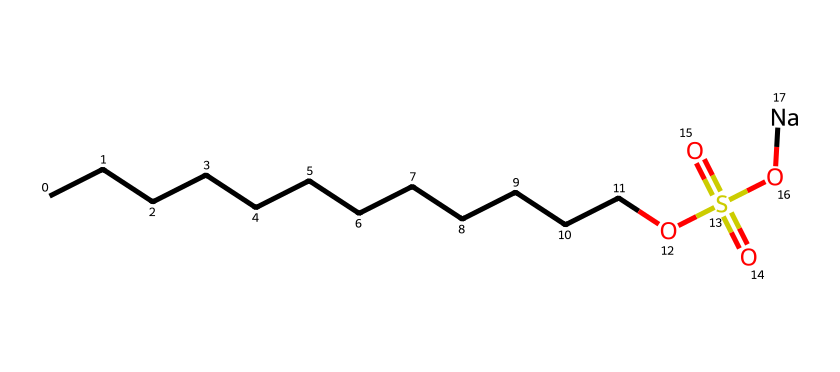What is the total number of carbon atoms in this chemical? The SMILES representation shows a long carbon chain indicated by the 'C' characters. Counting the 'C' characters, there are 12 carbon atoms.
Answer: twelve What is the functional group indicated by 'OS(=O)(=O)O'? This part of the SMILES represents a sulfonate group, as evidenced by the presence of sulfur (S) with three oxygens (O) attached, which are typical of sulfonate groups.
Answer: sulfonate How many oxygen atoms are present in this chemical? The SMILES includes four 'O' characters (three from the sulfonate group and one from the hydroxyl part), indicating a total of four oxygen atoms.
Answer: four What role does the sodium ion 'Na' play in this chemical? The sodium ion acts as a counterion for the sulfonate group, helping to balance the negative charge of the sulfonic acid component which contributes to the solubility and effectiveness of the detergent.
Answer: counterion Which part of this chemical structure contributes to its detergent properties? The long hydrocarbon chain (CCCCCCCCCCCC), along with the sulfonate group, makes this molecule amphiphilic, allowing it to interact with both hydrophobic stains and water, which is crucial for its detergent action.
Answer: hydrocarbon chain What is the importance of the sulfonate group in this detergent? The sulfonate group enhances the water solubility and cleaning action of the detergent, making it effective in breaking down and removing stains.
Answer: enhances solubility How does the chain length of this detergent influence its cleaning efficacy? A longer carbon chain typically increases the detergent's ability to solubilize oils and fat-based stains, making it more effective in those types of cleaning scenarios.
Answer: increases cleaning efficacy 